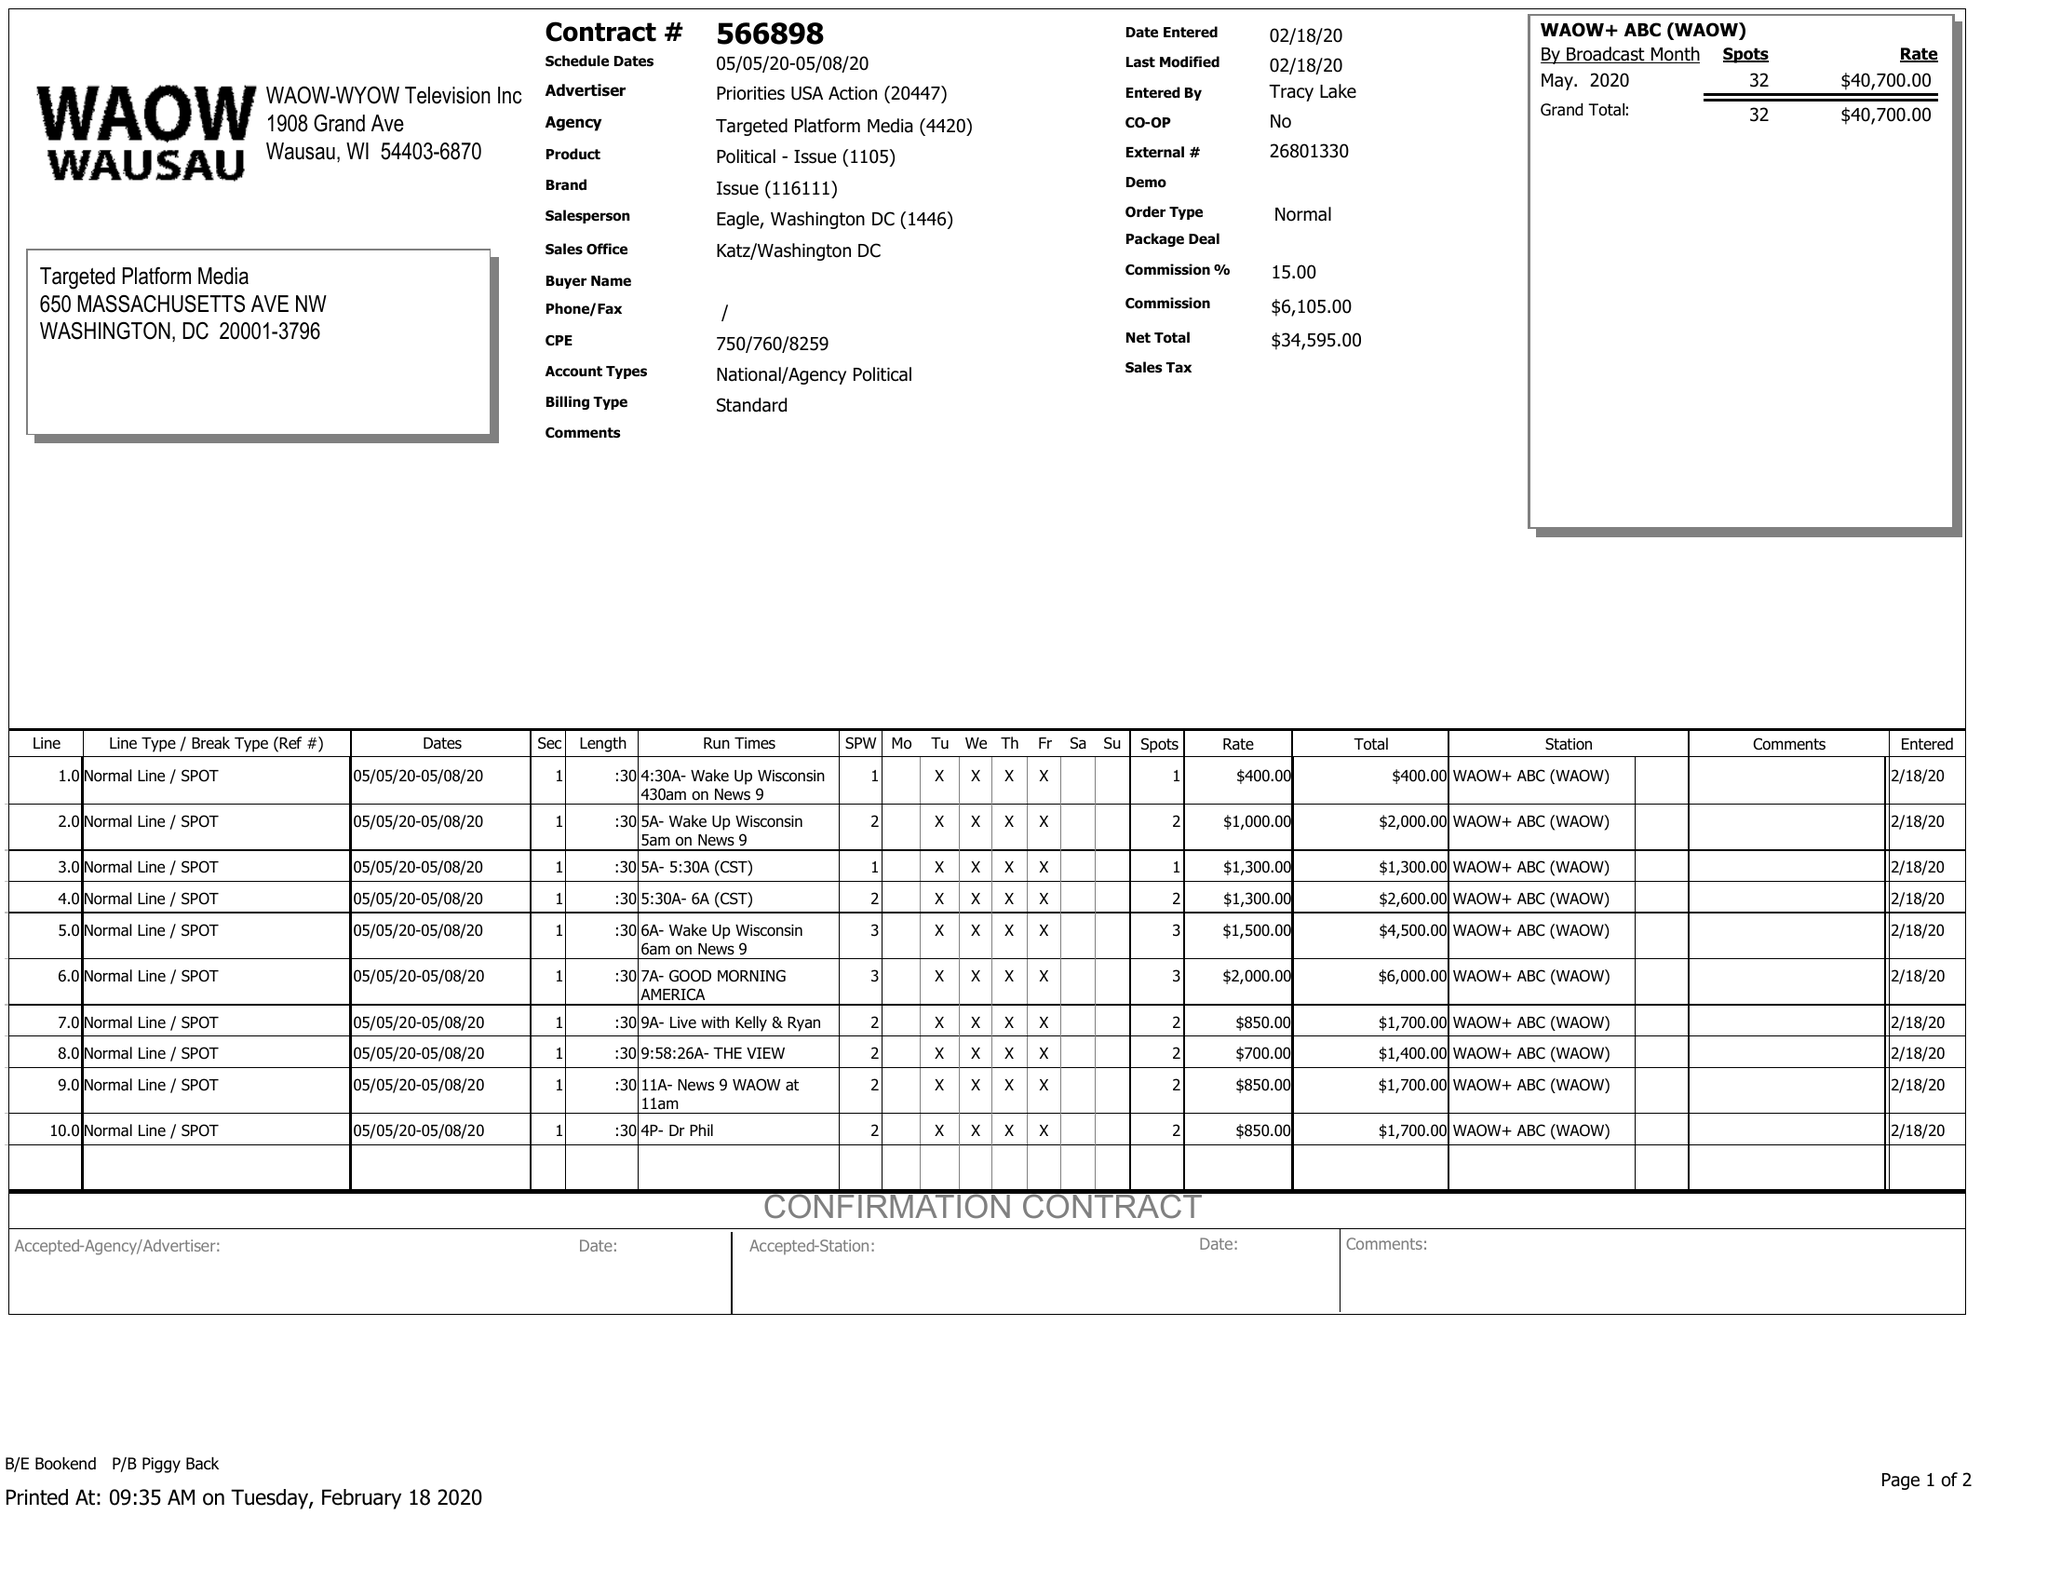What is the value for the contract_num?
Answer the question using a single word or phrase. 566898 